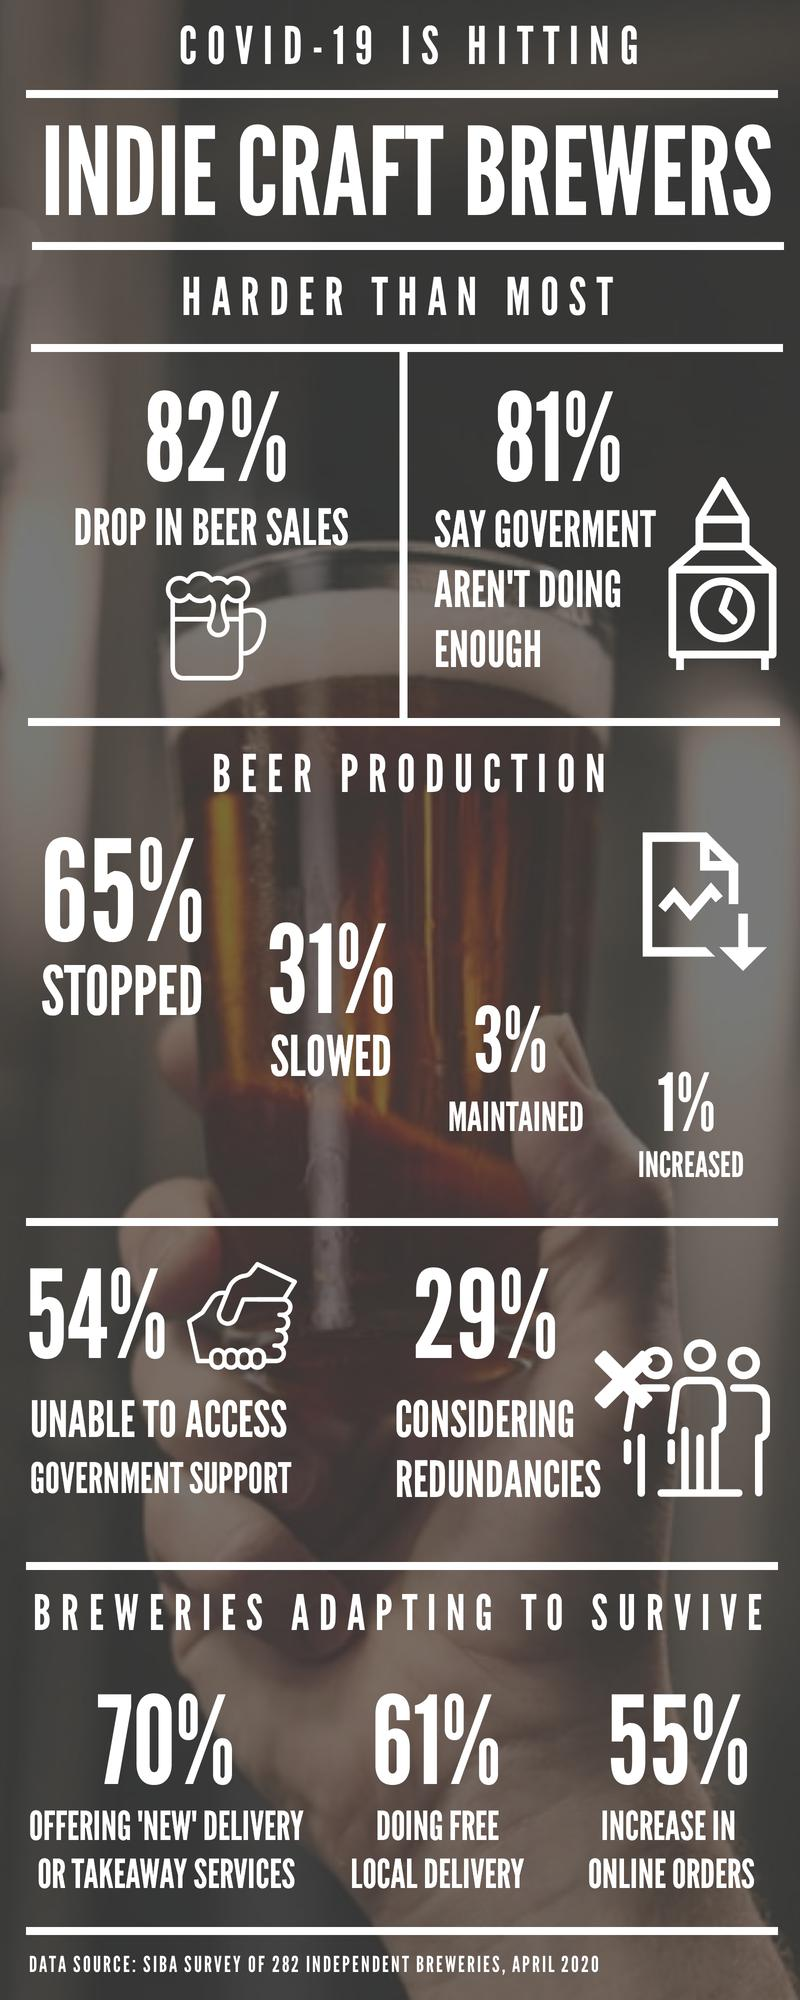Highlight a few significant elements in this photo. Approximately 39% of local deliveries are paid. According to a recent survey, 46% of people are able to access government support for various needs. According to a recent survey, only 19% of people believe that the government is doing enough to address the current issues. 